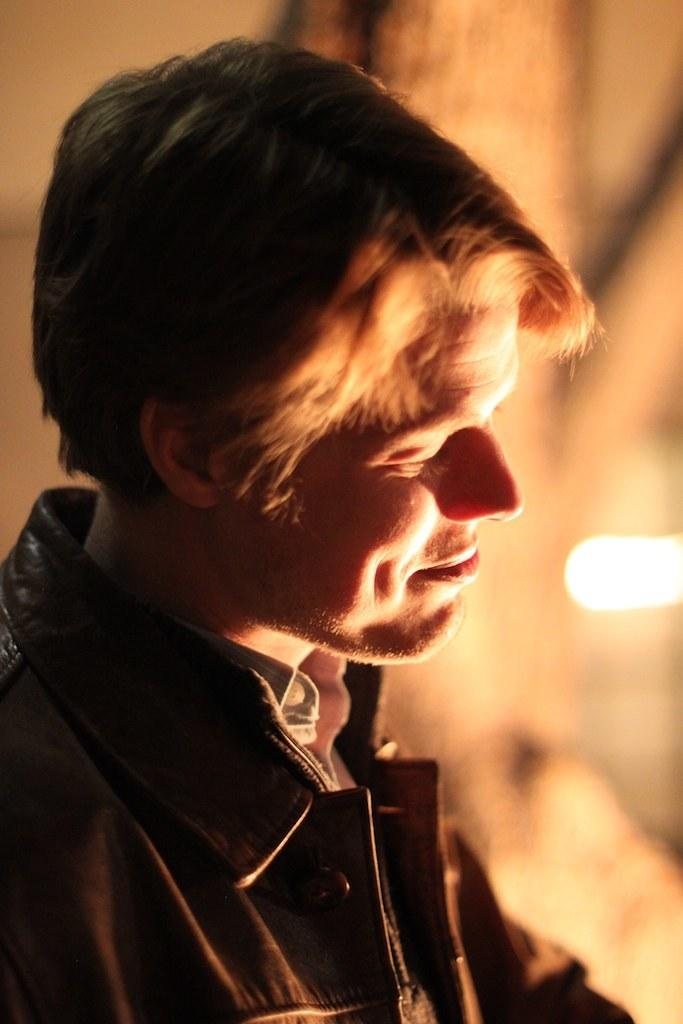Who is present in the image? There is a man in the image. What expression does the man have? The man is smiling. Can you describe the background of the image? The background of the image is blurry. What type of watch can be seen on the man's wrist in the image? There is no watch visible on the man's wrist in the image. 